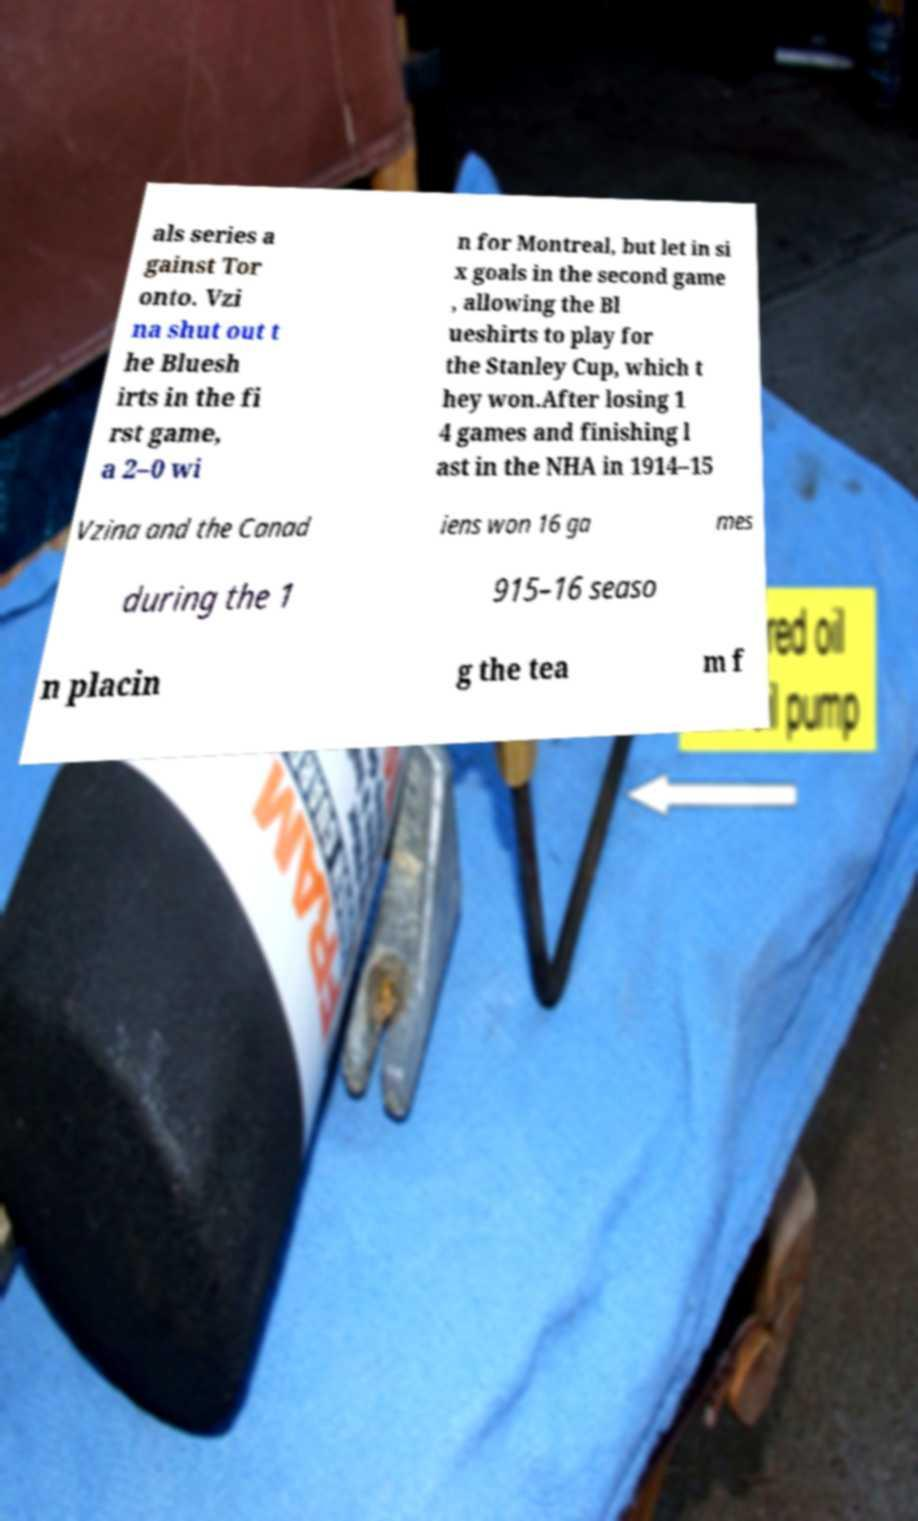Can you accurately transcribe the text from the provided image for me? als series a gainst Tor onto. Vzi na shut out t he Bluesh irts in the fi rst game, a 2–0 wi n for Montreal, but let in si x goals in the second game , allowing the Bl ueshirts to play for the Stanley Cup, which t hey won.After losing 1 4 games and finishing l ast in the NHA in 1914–15 Vzina and the Canad iens won 16 ga mes during the 1 915–16 seaso n placin g the tea m f 